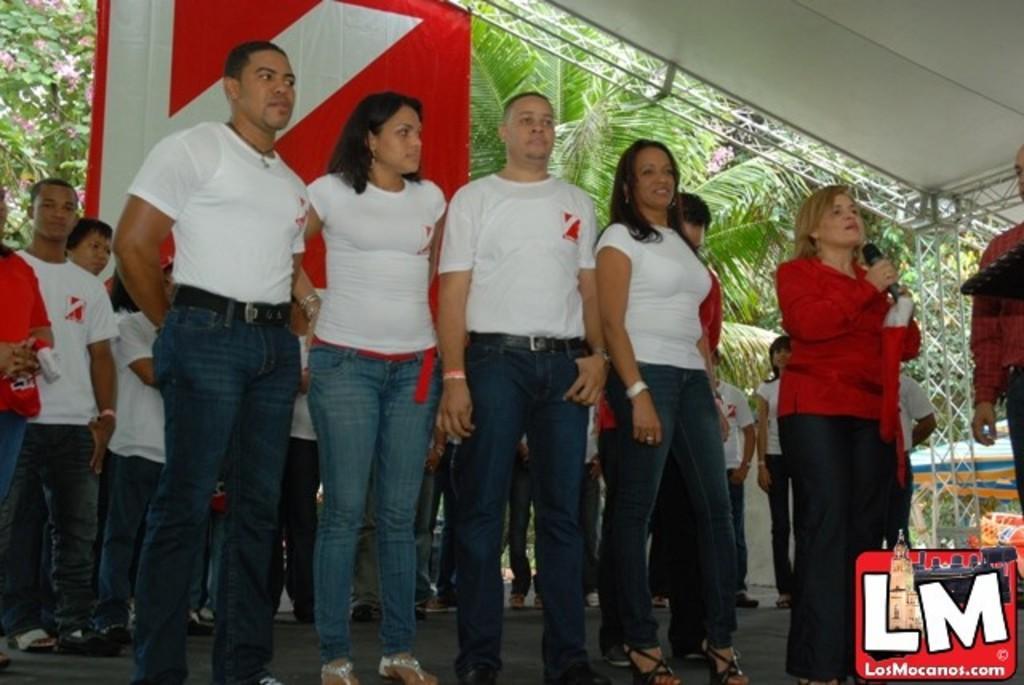How would you summarize this image in a sentence or two? In this image, we can see a group of people standing on the floor. On the right side of the image, we can see a woman holding a microphone. In the background, there are trees, rods, banner and shed. In the bottom right corner, there is a logo and few objects. 